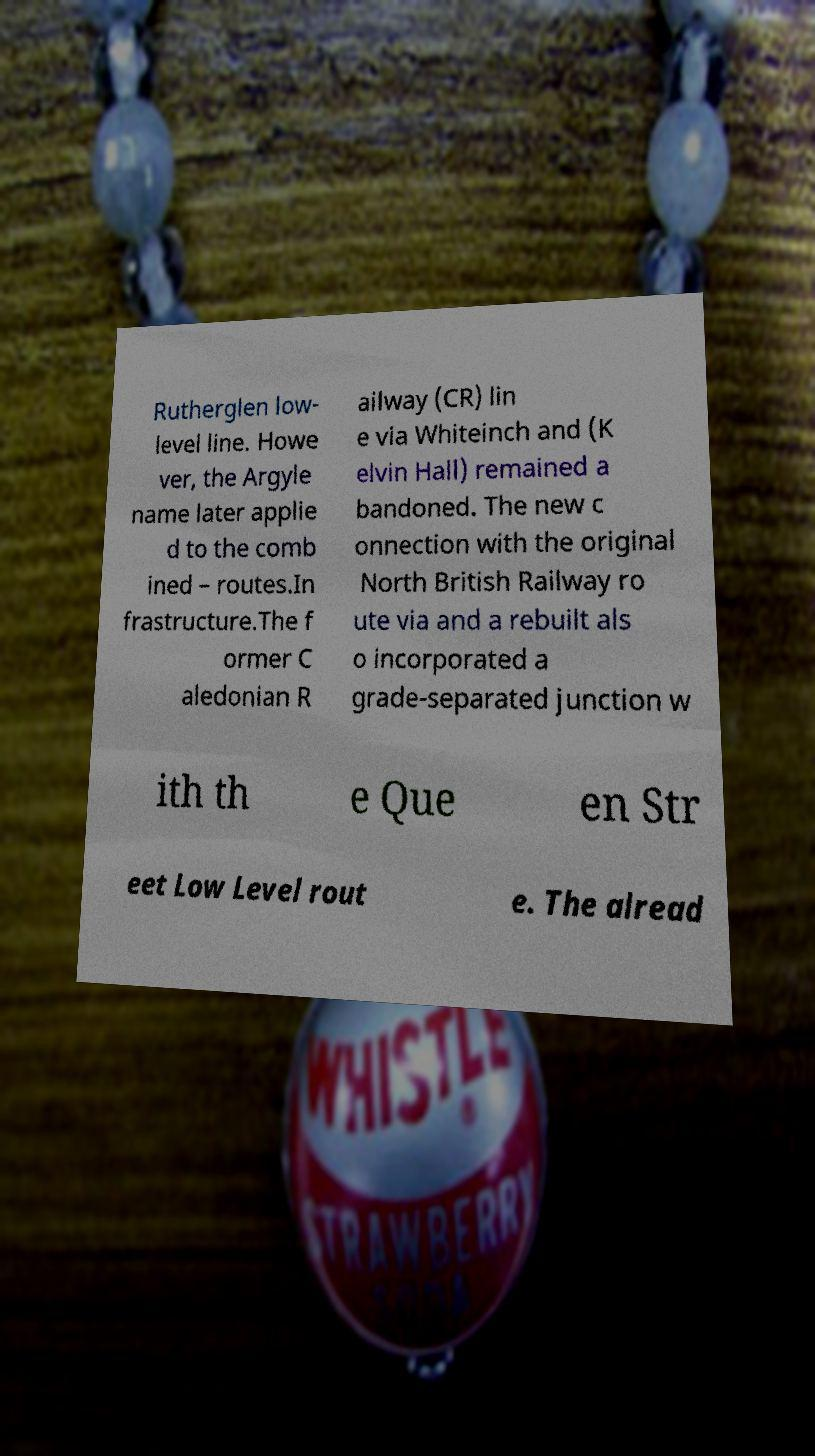For documentation purposes, I need the text within this image transcribed. Could you provide that? Rutherglen low- level line. Howe ver, the Argyle name later applie d to the comb ined – routes.In frastructure.The f ormer C aledonian R ailway (CR) lin e via Whiteinch and (K elvin Hall) remained a bandoned. The new c onnection with the original North British Railway ro ute via and a rebuilt als o incorporated a grade-separated junction w ith th e Que en Str eet Low Level rout e. The alread 